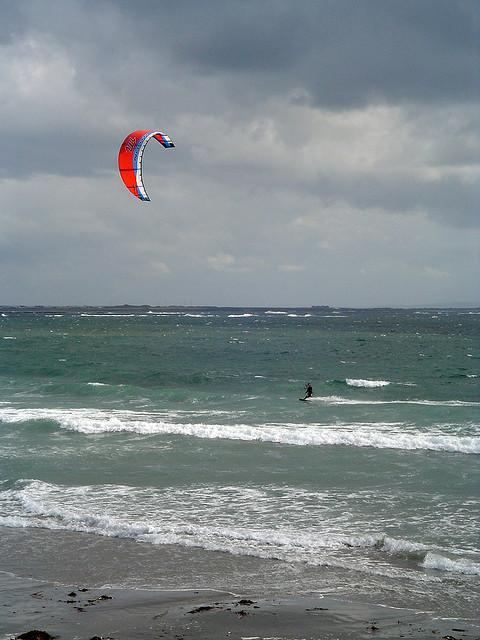What is the boarder about to hit?

Choices:
A) shark
B) abyss
C) beach
D) tidal wave beach 